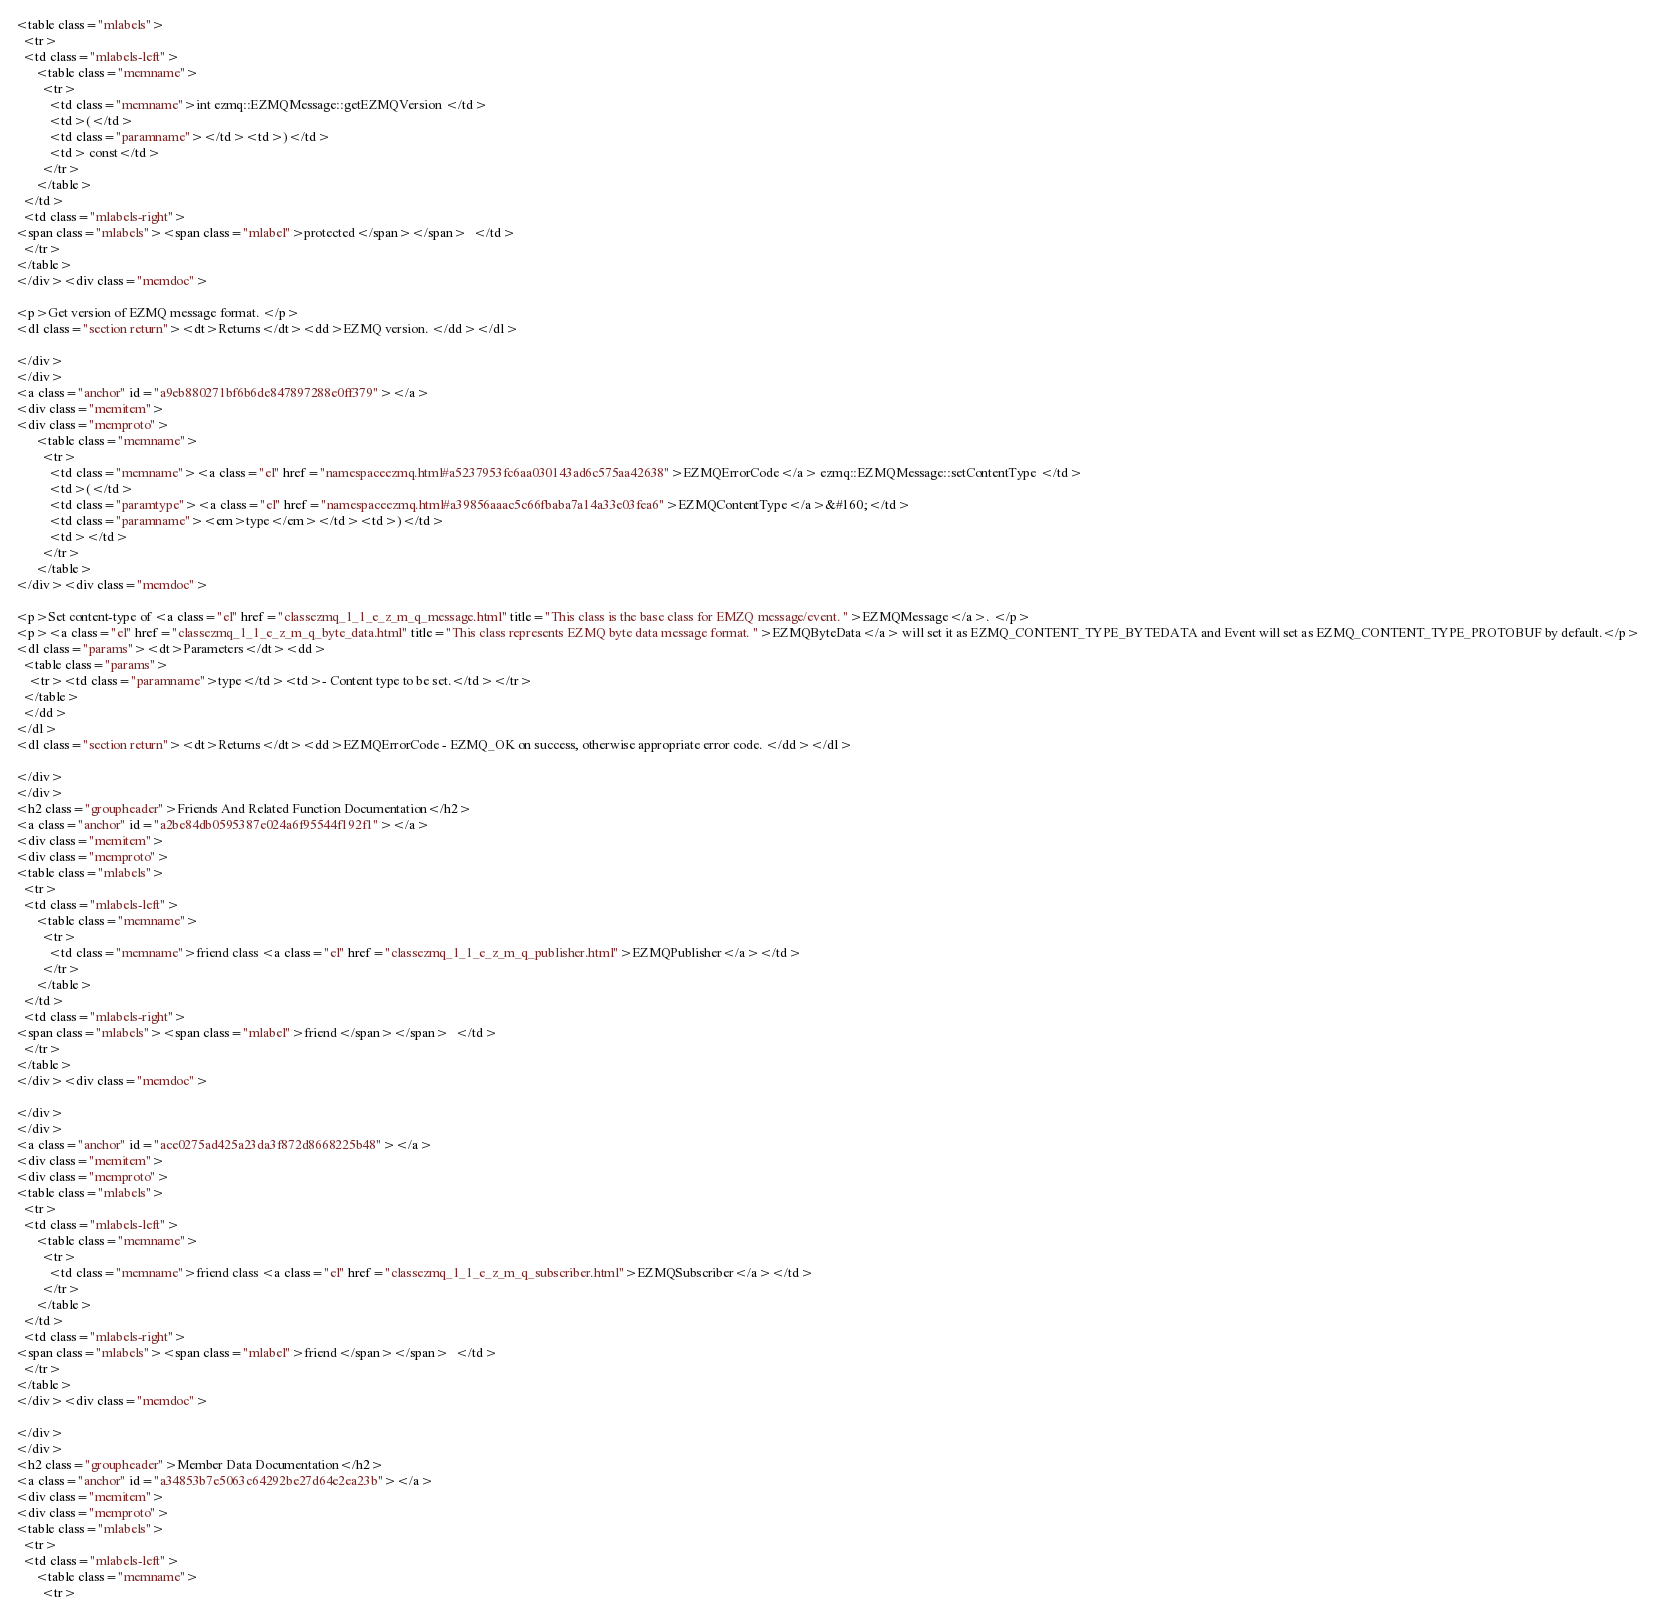Convert code to text. <code><loc_0><loc_0><loc_500><loc_500><_HTML_><table class="mlabels">
  <tr>
  <td class="mlabels-left">
      <table class="memname">
        <tr>
          <td class="memname">int ezmq::EZMQMessage::getEZMQVersion </td>
          <td>(</td>
          <td class="paramname"></td><td>)</td>
          <td> const</td>
        </tr>
      </table>
  </td>
  <td class="mlabels-right">
<span class="mlabels"><span class="mlabel">protected</span></span>  </td>
  </tr>
</table>
</div><div class="memdoc">

<p>Get version of EZMQ message format. </p>
<dl class="section return"><dt>Returns</dt><dd>EZMQ version. </dd></dl>

</div>
</div>
<a class="anchor" id="a9eb880271bf6b6de847897288e0ff379"></a>
<div class="memitem">
<div class="memproto">
      <table class="memname">
        <tr>
          <td class="memname"><a class="el" href="namespaceezmq.html#a5237953fc6aa030143ad6c575aa42638">EZMQErrorCode</a> ezmq::EZMQMessage::setContentType </td>
          <td>(</td>
          <td class="paramtype"><a class="el" href="namespaceezmq.html#a39856aaac5c66fbaba7a14a33e03fea6">EZMQContentType</a>&#160;</td>
          <td class="paramname"><em>type</em></td><td>)</td>
          <td></td>
        </tr>
      </table>
</div><div class="memdoc">

<p>Set content-type of <a class="el" href="classezmq_1_1_e_z_m_q_message.html" title="This class is the base class for EMZQ message/event. ">EZMQMessage</a>. </p>
<p><a class="el" href="classezmq_1_1_e_z_m_q_byte_data.html" title="This class represents EZMQ byte data message format. ">EZMQByteData</a> will set it as EZMQ_CONTENT_TYPE_BYTEDATA and Event will set as EZMQ_CONTENT_TYPE_PROTOBUF by default.</p>
<dl class="params"><dt>Parameters</dt><dd>
  <table class="params">
    <tr><td class="paramname">type</td><td>- Content type to be set.</td></tr>
  </table>
  </dd>
</dl>
<dl class="section return"><dt>Returns</dt><dd>EZMQErrorCode - EZMQ_OK on success, otherwise appropriate error code. </dd></dl>

</div>
</div>
<h2 class="groupheader">Friends And Related Function Documentation</h2>
<a class="anchor" id="a2be84db0595387e024a6f95544f192f1"></a>
<div class="memitem">
<div class="memproto">
<table class="mlabels">
  <tr>
  <td class="mlabels-left">
      <table class="memname">
        <tr>
          <td class="memname">friend class <a class="el" href="classezmq_1_1_e_z_m_q_publisher.html">EZMQPublisher</a></td>
        </tr>
      </table>
  </td>
  <td class="mlabels-right">
<span class="mlabels"><span class="mlabel">friend</span></span>  </td>
  </tr>
</table>
</div><div class="memdoc">

</div>
</div>
<a class="anchor" id="ace0275ad425a23da3f872d8668225b48"></a>
<div class="memitem">
<div class="memproto">
<table class="mlabels">
  <tr>
  <td class="mlabels-left">
      <table class="memname">
        <tr>
          <td class="memname">friend class <a class="el" href="classezmq_1_1_e_z_m_q_subscriber.html">EZMQSubscriber</a></td>
        </tr>
      </table>
  </td>
  <td class="mlabels-right">
<span class="mlabels"><span class="mlabel">friend</span></span>  </td>
  </tr>
</table>
</div><div class="memdoc">

</div>
</div>
<h2 class="groupheader">Member Data Documentation</h2>
<a class="anchor" id="a34853b7e5063c64292be27d64e2ea23b"></a>
<div class="memitem">
<div class="memproto">
<table class="mlabels">
  <tr>
  <td class="mlabels-left">
      <table class="memname">
        <tr></code> 